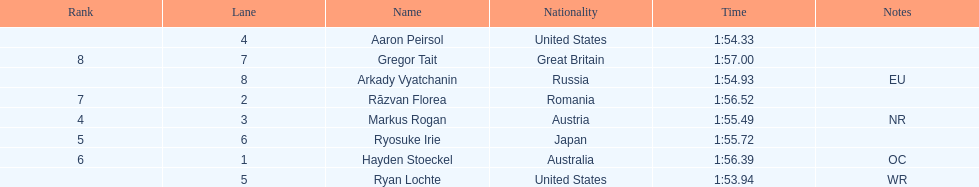How many swimmers were from the us? 2. 